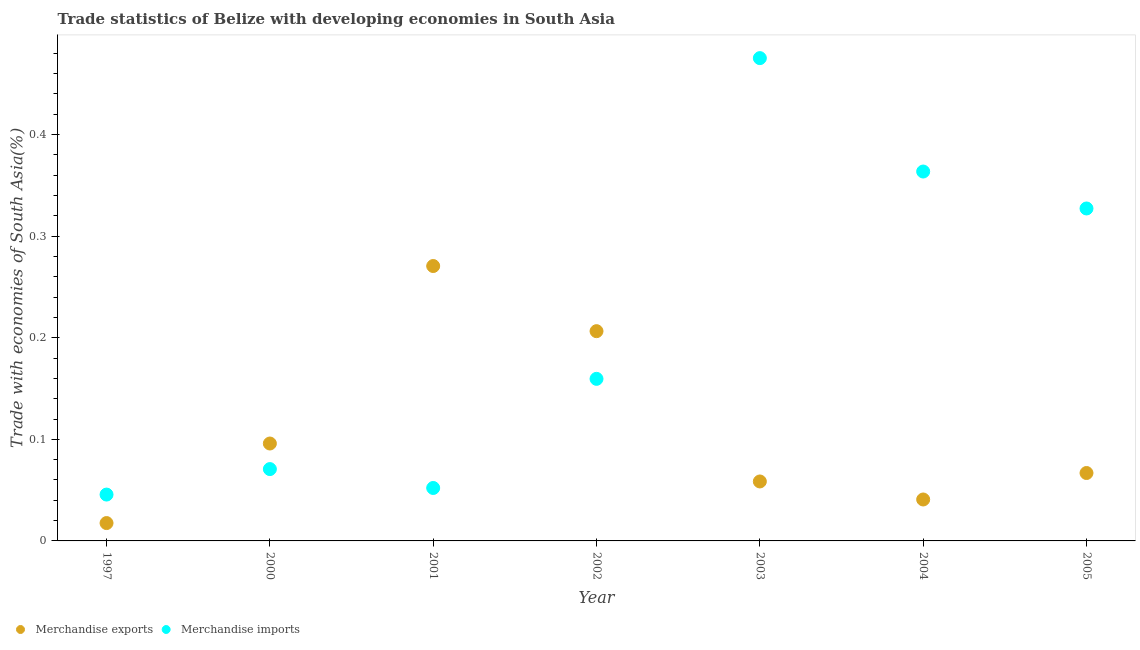How many different coloured dotlines are there?
Make the answer very short. 2. Is the number of dotlines equal to the number of legend labels?
Your answer should be compact. Yes. What is the merchandise imports in 1997?
Give a very brief answer. 0.05. Across all years, what is the maximum merchandise imports?
Your answer should be very brief. 0.48. Across all years, what is the minimum merchandise imports?
Make the answer very short. 0.05. What is the total merchandise exports in the graph?
Your answer should be very brief. 0.76. What is the difference between the merchandise imports in 2000 and that in 2004?
Offer a terse response. -0.29. What is the difference between the merchandise imports in 2000 and the merchandise exports in 2004?
Offer a terse response. 0.03. What is the average merchandise exports per year?
Provide a succinct answer. 0.11. In the year 2004, what is the difference between the merchandise imports and merchandise exports?
Provide a succinct answer. 0.32. In how many years, is the merchandise exports greater than 0.46 %?
Offer a terse response. 0. What is the ratio of the merchandise exports in 2003 to that in 2005?
Keep it short and to the point. 0.88. Is the difference between the merchandise exports in 2000 and 2005 greater than the difference between the merchandise imports in 2000 and 2005?
Your answer should be compact. Yes. What is the difference between the highest and the second highest merchandise imports?
Provide a succinct answer. 0.11. What is the difference between the highest and the lowest merchandise exports?
Your answer should be compact. 0.25. Is the sum of the merchandise exports in 2002 and 2003 greater than the maximum merchandise imports across all years?
Offer a terse response. No. Is the merchandise exports strictly less than the merchandise imports over the years?
Your answer should be very brief. No. How many years are there in the graph?
Offer a very short reply. 7. Does the graph contain any zero values?
Provide a short and direct response. No. Where does the legend appear in the graph?
Provide a succinct answer. Bottom left. How many legend labels are there?
Give a very brief answer. 2. How are the legend labels stacked?
Keep it short and to the point. Horizontal. What is the title of the graph?
Provide a succinct answer. Trade statistics of Belize with developing economies in South Asia. What is the label or title of the X-axis?
Provide a succinct answer. Year. What is the label or title of the Y-axis?
Keep it short and to the point. Trade with economies of South Asia(%). What is the Trade with economies of South Asia(%) in Merchandise exports in 1997?
Your answer should be very brief. 0.02. What is the Trade with economies of South Asia(%) of Merchandise imports in 1997?
Make the answer very short. 0.05. What is the Trade with economies of South Asia(%) of Merchandise exports in 2000?
Your answer should be very brief. 0.1. What is the Trade with economies of South Asia(%) in Merchandise imports in 2000?
Make the answer very short. 0.07. What is the Trade with economies of South Asia(%) in Merchandise exports in 2001?
Your answer should be compact. 0.27. What is the Trade with economies of South Asia(%) of Merchandise imports in 2001?
Offer a terse response. 0.05. What is the Trade with economies of South Asia(%) of Merchandise exports in 2002?
Your answer should be compact. 0.21. What is the Trade with economies of South Asia(%) in Merchandise imports in 2002?
Your answer should be very brief. 0.16. What is the Trade with economies of South Asia(%) of Merchandise exports in 2003?
Offer a very short reply. 0.06. What is the Trade with economies of South Asia(%) in Merchandise imports in 2003?
Offer a very short reply. 0.48. What is the Trade with economies of South Asia(%) of Merchandise exports in 2004?
Provide a short and direct response. 0.04. What is the Trade with economies of South Asia(%) of Merchandise imports in 2004?
Provide a short and direct response. 0.36. What is the Trade with economies of South Asia(%) of Merchandise exports in 2005?
Keep it short and to the point. 0.07. What is the Trade with economies of South Asia(%) in Merchandise imports in 2005?
Your response must be concise. 0.33. Across all years, what is the maximum Trade with economies of South Asia(%) in Merchandise exports?
Your response must be concise. 0.27. Across all years, what is the maximum Trade with economies of South Asia(%) in Merchandise imports?
Keep it short and to the point. 0.48. Across all years, what is the minimum Trade with economies of South Asia(%) of Merchandise exports?
Give a very brief answer. 0.02. Across all years, what is the minimum Trade with economies of South Asia(%) in Merchandise imports?
Your answer should be very brief. 0.05. What is the total Trade with economies of South Asia(%) of Merchandise exports in the graph?
Provide a short and direct response. 0.76. What is the total Trade with economies of South Asia(%) in Merchandise imports in the graph?
Offer a terse response. 1.49. What is the difference between the Trade with economies of South Asia(%) in Merchandise exports in 1997 and that in 2000?
Your answer should be compact. -0.08. What is the difference between the Trade with economies of South Asia(%) in Merchandise imports in 1997 and that in 2000?
Offer a terse response. -0.03. What is the difference between the Trade with economies of South Asia(%) of Merchandise exports in 1997 and that in 2001?
Make the answer very short. -0.25. What is the difference between the Trade with economies of South Asia(%) in Merchandise imports in 1997 and that in 2001?
Keep it short and to the point. -0.01. What is the difference between the Trade with economies of South Asia(%) in Merchandise exports in 1997 and that in 2002?
Make the answer very short. -0.19. What is the difference between the Trade with economies of South Asia(%) in Merchandise imports in 1997 and that in 2002?
Provide a succinct answer. -0.11. What is the difference between the Trade with economies of South Asia(%) of Merchandise exports in 1997 and that in 2003?
Your answer should be very brief. -0.04. What is the difference between the Trade with economies of South Asia(%) of Merchandise imports in 1997 and that in 2003?
Provide a short and direct response. -0.43. What is the difference between the Trade with economies of South Asia(%) of Merchandise exports in 1997 and that in 2004?
Provide a short and direct response. -0.02. What is the difference between the Trade with economies of South Asia(%) in Merchandise imports in 1997 and that in 2004?
Make the answer very short. -0.32. What is the difference between the Trade with economies of South Asia(%) of Merchandise exports in 1997 and that in 2005?
Your response must be concise. -0.05. What is the difference between the Trade with economies of South Asia(%) in Merchandise imports in 1997 and that in 2005?
Offer a terse response. -0.28. What is the difference between the Trade with economies of South Asia(%) of Merchandise exports in 2000 and that in 2001?
Your answer should be very brief. -0.17. What is the difference between the Trade with economies of South Asia(%) of Merchandise imports in 2000 and that in 2001?
Ensure brevity in your answer.  0.02. What is the difference between the Trade with economies of South Asia(%) in Merchandise exports in 2000 and that in 2002?
Offer a very short reply. -0.11. What is the difference between the Trade with economies of South Asia(%) in Merchandise imports in 2000 and that in 2002?
Your answer should be compact. -0.09. What is the difference between the Trade with economies of South Asia(%) in Merchandise exports in 2000 and that in 2003?
Keep it short and to the point. 0.04. What is the difference between the Trade with economies of South Asia(%) in Merchandise imports in 2000 and that in 2003?
Your answer should be very brief. -0.4. What is the difference between the Trade with economies of South Asia(%) in Merchandise exports in 2000 and that in 2004?
Give a very brief answer. 0.06. What is the difference between the Trade with economies of South Asia(%) in Merchandise imports in 2000 and that in 2004?
Provide a short and direct response. -0.29. What is the difference between the Trade with economies of South Asia(%) in Merchandise exports in 2000 and that in 2005?
Your response must be concise. 0.03. What is the difference between the Trade with economies of South Asia(%) in Merchandise imports in 2000 and that in 2005?
Your response must be concise. -0.26. What is the difference between the Trade with economies of South Asia(%) of Merchandise exports in 2001 and that in 2002?
Ensure brevity in your answer.  0.06. What is the difference between the Trade with economies of South Asia(%) of Merchandise imports in 2001 and that in 2002?
Ensure brevity in your answer.  -0.11. What is the difference between the Trade with economies of South Asia(%) in Merchandise exports in 2001 and that in 2003?
Keep it short and to the point. 0.21. What is the difference between the Trade with economies of South Asia(%) in Merchandise imports in 2001 and that in 2003?
Ensure brevity in your answer.  -0.42. What is the difference between the Trade with economies of South Asia(%) in Merchandise exports in 2001 and that in 2004?
Ensure brevity in your answer.  0.23. What is the difference between the Trade with economies of South Asia(%) of Merchandise imports in 2001 and that in 2004?
Offer a very short reply. -0.31. What is the difference between the Trade with economies of South Asia(%) of Merchandise exports in 2001 and that in 2005?
Make the answer very short. 0.2. What is the difference between the Trade with economies of South Asia(%) in Merchandise imports in 2001 and that in 2005?
Offer a very short reply. -0.28. What is the difference between the Trade with economies of South Asia(%) of Merchandise exports in 2002 and that in 2003?
Make the answer very short. 0.15. What is the difference between the Trade with economies of South Asia(%) of Merchandise imports in 2002 and that in 2003?
Provide a succinct answer. -0.32. What is the difference between the Trade with economies of South Asia(%) of Merchandise exports in 2002 and that in 2004?
Make the answer very short. 0.17. What is the difference between the Trade with economies of South Asia(%) of Merchandise imports in 2002 and that in 2004?
Provide a succinct answer. -0.2. What is the difference between the Trade with economies of South Asia(%) in Merchandise exports in 2002 and that in 2005?
Your response must be concise. 0.14. What is the difference between the Trade with economies of South Asia(%) in Merchandise imports in 2002 and that in 2005?
Your answer should be compact. -0.17. What is the difference between the Trade with economies of South Asia(%) of Merchandise exports in 2003 and that in 2004?
Offer a very short reply. 0.02. What is the difference between the Trade with economies of South Asia(%) of Merchandise imports in 2003 and that in 2004?
Your answer should be very brief. 0.11. What is the difference between the Trade with economies of South Asia(%) of Merchandise exports in 2003 and that in 2005?
Provide a succinct answer. -0.01. What is the difference between the Trade with economies of South Asia(%) of Merchandise imports in 2003 and that in 2005?
Make the answer very short. 0.15. What is the difference between the Trade with economies of South Asia(%) in Merchandise exports in 2004 and that in 2005?
Your answer should be compact. -0.03. What is the difference between the Trade with economies of South Asia(%) of Merchandise imports in 2004 and that in 2005?
Your answer should be very brief. 0.04. What is the difference between the Trade with economies of South Asia(%) in Merchandise exports in 1997 and the Trade with economies of South Asia(%) in Merchandise imports in 2000?
Provide a succinct answer. -0.05. What is the difference between the Trade with economies of South Asia(%) of Merchandise exports in 1997 and the Trade with economies of South Asia(%) of Merchandise imports in 2001?
Keep it short and to the point. -0.03. What is the difference between the Trade with economies of South Asia(%) in Merchandise exports in 1997 and the Trade with economies of South Asia(%) in Merchandise imports in 2002?
Ensure brevity in your answer.  -0.14. What is the difference between the Trade with economies of South Asia(%) of Merchandise exports in 1997 and the Trade with economies of South Asia(%) of Merchandise imports in 2003?
Offer a very short reply. -0.46. What is the difference between the Trade with economies of South Asia(%) of Merchandise exports in 1997 and the Trade with economies of South Asia(%) of Merchandise imports in 2004?
Give a very brief answer. -0.35. What is the difference between the Trade with economies of South Asia(%) in Merchandise exports in 1997 and the Trade with economies of South Asia(%) in Merchandise imports in 2005?
Offer a very short reply. -0.31. What is the difference between the Trade with economies of South Asia(%) of Merchandise exports in 2000 and the Trade with economies of South Asia(%) of Merchandise imports in 2001?
Offer a terse response. 0.04. What is the difference between the Trade with economies of South Asia(%) in Merchandise exports in 2000 and the Trade with economies of South Asia(%) in Merchandise imports in 2002?
Provide a succinct answer. -0.06. What is the difference between the Trade with economies of South Asia(%) of Merchandise exports in 2000 and the Trade with economies of South Asia(%) of Merchandise imports in 2003?
Keep it short and to the point. -0.38. What is the difference between the Trade with economies of South Asia(%) in Merchandise exports in 2000 and the Trade with economies of South Asia(%) in Merchandise imports in 2004?
Ensure brevity in your answer.  -0.27. What is the difference between the Trade with economies of South Asia(%) in Merchandise exports in 2000 and the Trade with economies of South Asia(%) in Merchandise imports in 2005?
Provide a succinct answer. -0.23. What is the difference between the Trade with economies of South Asia(%) of Merchandise exports in 2001 and the Trade with economies of South Asia(%) of Merchandise imports in 2002?
Offer a very short reply. 0.11. What is the difference between the Trade with economies of South Asia(%) of Merchandise exports in 2001 and the Trade with economies of South Asia(%) of Merchandise imports in 2003?
Make the answer very short. -0.2. What is the difference between the Trade with economies of South Asia(%) in Merchandise exports in 2001 and the Trade with economies of South Asia(%) in Merchandise imports in 2004?
Offer a very short reply. -0.09. What is the difference between the Trade with economies of South Asia(%) of Merchandise exports in 2001 and the Trade with economies of South Asia(%) of Merchandise imports in 2005?
Ensure brevity in your answer.  -0.06. What is the difference between the Trade with economies of South Asia(%) in Merchandise exports in 2002 and the Trade with economies of South Asia(%) in Merchandise imports in 2003?
Make the answer very short. -0.27. What is the difference between the Trade with economies of South Asia(%) of Merchandise exports in 2002 and the Trade with economies of South Asia(%) of Merchandise imports in 2004?
Ensure brevity in your answer.  -0.16. What is the difference between the Trade with economies of South Asia(%) in Merchandise exports in 2002 and the Trade with economies of South Asia(%) in Merchandise imports in 2005?
Give a very brief answer. -0.12. What is the difference between the Trade with economies of South Asia(%) in Merchandise exports in 2003 and the Trade with economies of South Asia(%) in Merchandise imports in 2004?
Offer a very short reply. -0.31. What is the difference between the Trade with economies of South Asia(%) of Merchandise exports in 2003 and the Trade with economies of South Asia(%) of Merchandise imports in 2005?
Provide a succinct answer. -0.27. What is the difference between the Trade with economies of South Asia(%) in Merchandise exports in 2004 and the Trade with economies of South Asia(%) in Merchandise imports in 2005?
Offer a very short reply. -0.29. What is the average Trade with economies of South Asia(%) in Merchandise exports per year?
Provide a short and direct response. 0.11. What is the average Trade with economies of South Asia(%) of Merchandise imports per year?
Your answer should be very brief. 0.21. In the year 1997, what is the difference between the Trade with economies of South Asia(%) in Merchandise exports and Trade with economies of South Asia(%) in Merchandise imports?
Make the answer very short. -0.03. In the year 2000, what is the difference between the Trade with economies of South Asia(%) of Merchandise exports and Trade with economies of South Asia(%) of Merchandise imports?
Your response must be concise. 0.03. In the year 2001, what is the difference between the Trade with economies of South Asia(%) in Merchandise exports and Trade with economies of South Asia(%) in Merchandise imports?
Offer a very short reply. 0.22. In the year 2002, what is the difference between the Trade with economies of South Asia(%) of Merchandise exports and Trade with economies of South Asia(%) of Merchandise imports?
Make the answer very short. 0.05. In the year 2003, what is the difference between the Trade with economies of South Asia(%) in Merchandise exports and Trade with economies of South Asia(%) in Merchandise imports?
Your answer should be compact. -0.42. In the year 2004, what is the difference between the Trade with economies of South Asia(%) of Merchandise exports and Trade with economies of South Asia(%) of Merchandise imports?
Your response must be concise. -0.32. In the year 2005, what is the difference between the Trade with economies of South Asia(%) in Merchandise exports and Trade with economies of South Asia(%) in Merchandise imports?
Your answer should be very brief. -0.26. What is the ratio of the Trade with economies of South Asia(%) of Merchandise exports in 1997 to that in 2000?
Provide a short and direct response. 0.18. What is the ratio of the Trade with economies of South Asia(%) of Merchandise imports in 1997 to that in 2000?
Provide a short and direct response. 0.65. What is the ratio of the Trade with economies of South Asia(%) of Merchandise exports in 1997 to that in 2001?
Your answer should be very brief. 0.07. What is the ratio of the Trade with economies of South Asia(%) in Merchandise imports in 1997 to that in 2001?
Offer a terse response. 0.88. What is the ratio of the Trade with economies of South Asia(%) in Merchandise exports in 1997 to that in 2002?
Make the answer very short. 0.09. What is the ratio of the Trade with economies of South Asia(%) of Merchandise imports in 1997 to that in 2002?
Your response must be concise. 0.29. What is the ratio of the Trade with economies of South Asia(%) of Merchandise exports in 1997 to that in 2003?
Your answer should be compact. 0.3. What is the ratio of the Trade with economies of South Asia(%) in Merchandise imports in 1997 to that in 2003?
Offer a terse response. 0.1. What is the ratio of the Trade with economies of South Asia(%) of Merchandise exports in 1997 to that in 2004?
Provide a short and direct response. 0.43. What is the ratio of the Trade with economies of South Asia(%) of Merchandise imports in 1997 to that in 2004?
Your answer should be compact. 0.13. What is the ratio of the Trade with economies of South Asia(%) in Merchandise exports in 1997 to that in 2005?
Give a very brief answer. 0.26. What is the ratio of the Trade with economies of South Asia(%) of Merchandise imports in 1997 to that in 2005?
Ensure brevity in your answer.  0.14. What is the ratio of the Trade with economies of South Asia(%) of Merchandise exports in 2000 to that in 2001?
Provide a succinct answer. 0.35. What is the ratio of the Trade with economies of South Asia(%) in Merchandise imports in 2000 to that in 2001?
Your response must be concise. 1.36. What is the ratio of the Trade with economies of South Asia(%) in Merchandise exports in 2000 to that in 2002?
Your answer should be very brief. 0.46. What is the ratio of the Trade with economies of South Asia(%) of Merchandise imports in 2000 to that in 2002?
Your answer should be very brief. 0.44. What is the ratio of the Trade with economies of South Asia(%) of Merchandise exports in 2000 to that in 2003?
Keep it short and to the point. 1.64. What is the ratio of the Trade with economies of South Asia(%) in Merchandise imports in 2000 to that in 2003?
Offer a very short reply. 0.15. What is the ratio of the Trade with economies of South Asia(%) of Merchandise exports in 2000 to that in 2004?
Your answer should be very brief. 2.35. What is the ratio of the Trade with economies of South Asia(%) of Merchandise imports in 2000 to that in 2004?
Make the answer very short. 0.19. What is the ratio of the Trade with economies of South Asia(%) of Merchandise exports in 2000 to that in 2005?
Offer a terse response. 1.43. What is the ratio of the Trade with economies of South Asia(%) of Merchandise imports in 2000 to that in 2005?
Give a very brief answer. 0.22. What is the ratio of the Trade with economies of South Asia(%) of Merchandise exports in 2001 to that in 2002?
Ensure brevity in your answer.  1.31. What is the ratio of the Trade with economies of South Asia(%) in Merchandise imports in 2001 to that in 2002?
Your answer should be compact. 0.33. What is the ratio of the Trade with economies of South Asia(%) of Merchandise exports in 2001 to that in 2003?
Give a very brief answer. 4.62. What is the ratio of the Trade with economies of South Asia(%) in Merchandise imports in 2001 to that in 2003?
Give a very brief answer. 0.11. What is the ratio of the Trade with economies of South Asia(%) of Merchandise exports in 2001 to that in 2004?
Keep it short and to the point. 6.63. What is the ratio of the Trade with economies of South Asia(%) in Merchandise imports in 2001 to that in 2004?
Offer a very short reply. 0.14. What is the ratio of the Trade with economies of South Asia(%) of Merchandise exports in 2001 to that in 2005?
Your answer should be compact. 4.05. What is the ratio of the Trade with economies of South Asia(%) in Merchandise imports in 2001 to that in 2005?
Ensure brevity in your answer.  0.16. What is the ratio of the Trade with economies of South Asia(%) of Merchandise exports in 2002 to that in 2003?
Offer a terse response. 3.53. What is the ratio of the Trade with economies of South Asia(%) in Merchandise imports in 2002 to that in 2003?
Your answer should be compact. 0.34. What is the ratio of the Trade with economies of South Asia(%) of Merchandise exports in 2002 to that in 2004?
Provide a short and direct response. 5.06. What is the ratio of the Trade with economies of South Asia(%) in Merchandise imports in 2002 to that in 2004?
Your answer should be very brief. 0.44. What is the ratio of the Trade with economies of South Asia(%) of Merchandise exports in 2002 to that in 2005?
Your answer should be compact. 3.09. What is the ratio of the Trade with economies of South Asia(%) of Merchandise imports in 2002 to that in 2005?
Your answer should be very brief. 0.49. What is the ratio of the Trade with economies of South Asia(%) of Merchandise exports in 2003 to that in 2004?
Offer a very short reply. 1.44. What is the ratio of the Trade with economies of South Asia(%) of Merchandise imports in 2003 to that in 2004?
Keep it short and to the point. 1.31. What is the ratio of the Trade with economies of South Asia(%) of Merchandise exports in 2003 to that in 2005?
Your response must be concise. 0.88. What is the ratio of the Trade with economies of South Asia(%) in Merchandise imports in 2003 to that in 2005?
Offer a very short reply. 1.45. What is the ratio of the Trade with economies of South Asia(%) in Merchandise exports in 2004 to that in 2005?
Give a very brief answer. 0.61. What is the difference between the highest and the second highest Trade with economies of South Asia(%) of Merchandise exports?
Make the answer very short. 0.06. What is the difference between the highest and the second highest Trade with economies of South Asia(%) of Merchandise imports?
Provide a short and direct response. 0.11. What is the difference between the highest and the lowest Trade with economies of South Asia(%) in Merchandise exports?
Ensure brevity in your answer.  0.25. What is the difference between the highest and the lowest Trade with economies of South Asia(%) of Merchandise imports?
Offer a terse response. 0.43. 